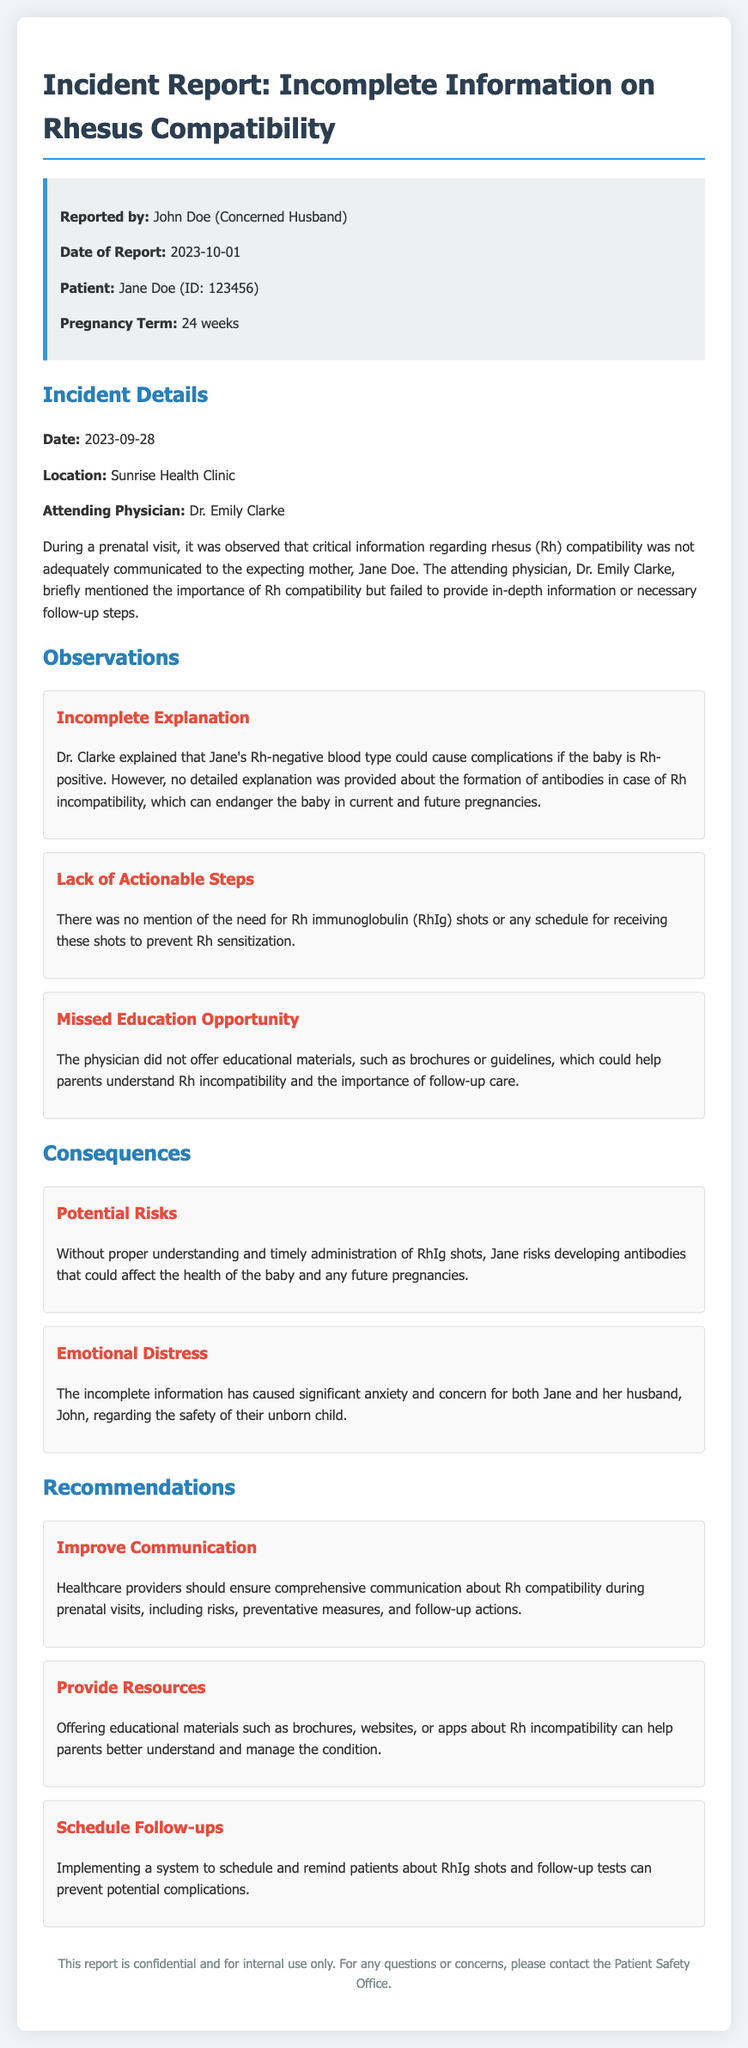what is the name of the concerned husband? The concerned husband who reported the incident is mentioned as John Doe.
Answer: John Doe what is the date of the report? The report states that it was filed on October 1, 2023.
Answer: 2023-10-01 what was the attending physician's name? The document specifies that Dr. Emily Clarke was the attending physician during the prenatal visit.
Answer: Dr. Emily Clarke what are the potential risks mentioned? The incident report highlights that without proper understanding and timely administration of RhIg shots, Jane risks developing antibodies, which could affect the health of the baby and future pregnancies.
Answer: Developing antibodies what was the recommended action to improve communication? One of the recommendations is to ensure comprehensive communication about Rh compatibility during prenatal visits.
Answer: Improve communication how many weeks was Jane's pregnancy at the time of the report? The document notes that Jane's pregnancy term was 24 weeks at the time of the report.
Answer: 24 weeks what educational materials were not offered during the visit? The report mentions that the physician did not offer educational materials such as brochures or guidelines about Rh incompatibility.
Answer: Brochures what caused emotional distress for Jane and John? The incomplete information given about Rh compatibility caused significant anxiety and concern for the couple regarding their unborn child's safety.
Answer: Incomplete information what was mentioned as a missed opportunity in the incident? The document states that there was a missed education opportunity as the physician did not provide educational materials to help parents understand Rh incompatibility.
Answer: Missed education opportunity how should healthcare providers communicate Rh compatibility? Healthcare providers should ensure comprehensive communication about Rh compatibility, including risks, preventative measures, and follow-up actions.
Answer: Comprehensive communication 